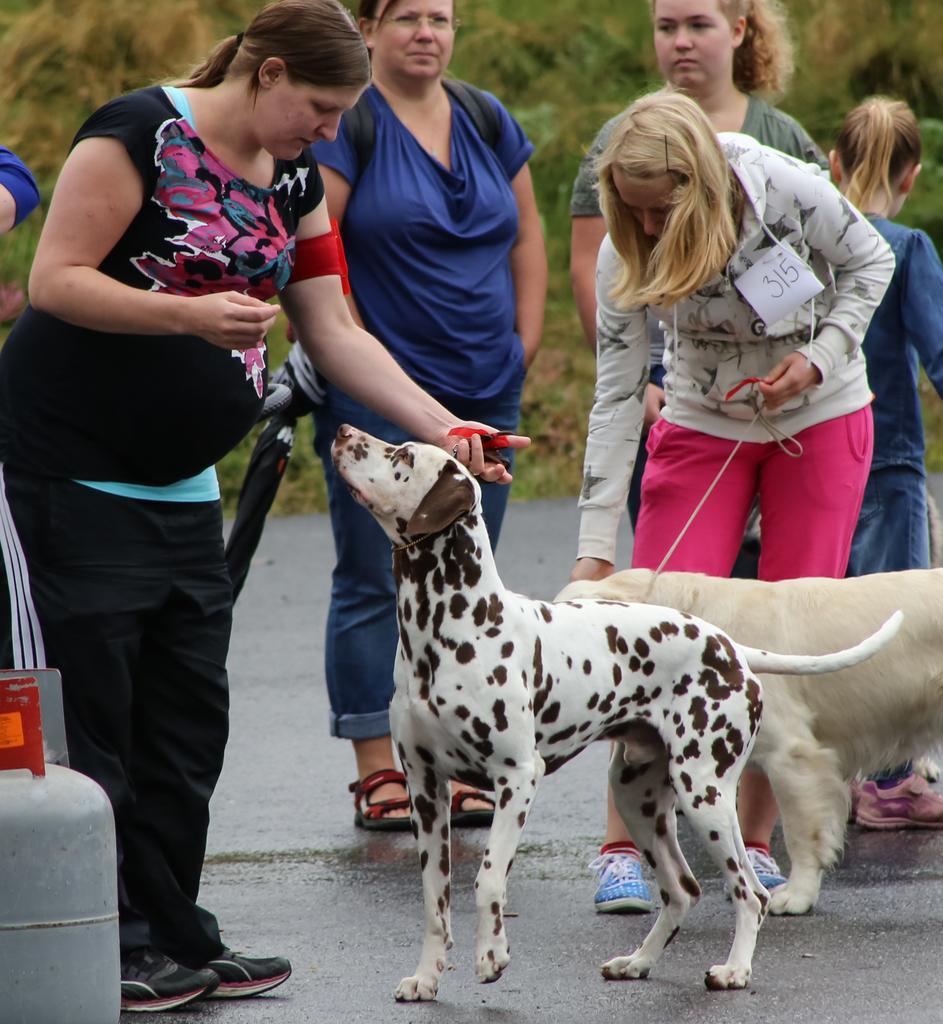Describe this image in one or two sentences. In the picture there are group of women pampering the dogs on the road,to the left there is a cylinder,the road is wet,in the background there are some trees and grass. 